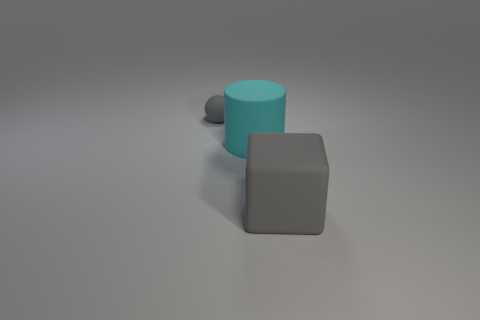Add 2 small matte things. How many objects exist? 5 Subtract all large blocks. Subtract all large cyan rubber objects. How many objects are left? 1 Add 3 cyan things. How many cyan things are left? 4 Add 3 small gray things. How many small gray things exist? 4 Subtract 0 red cylinders. How many objects are left? 3 Subtract all cubes. How many objects are left? 2 Subtract 1 cylinders. How many cylinders are left? 0 